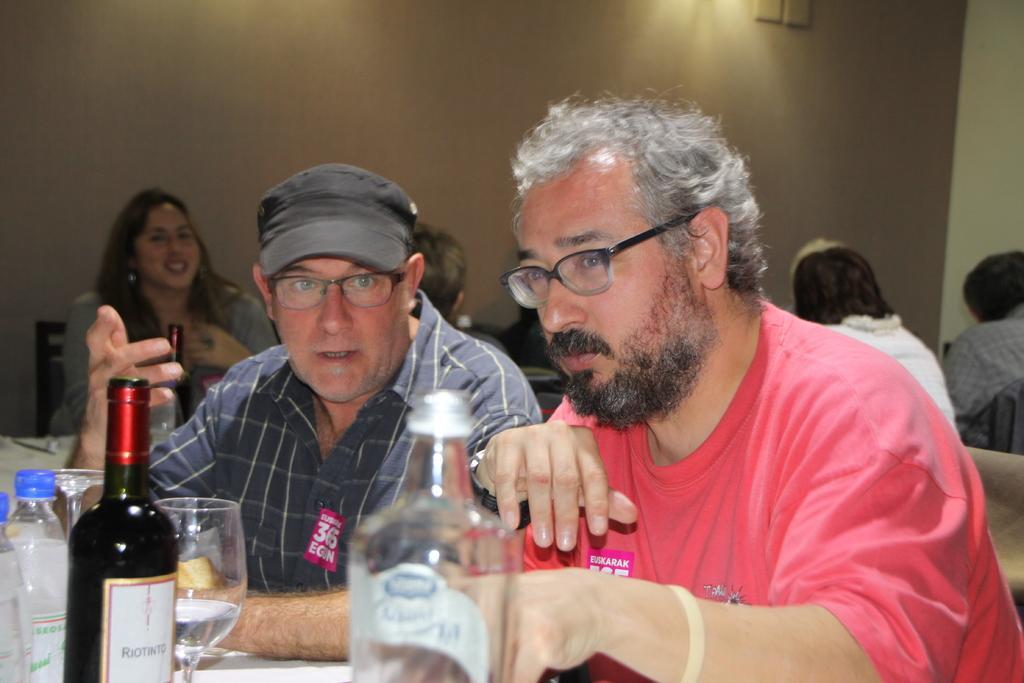Can you describe this image briefly? In this image I can see two people are sitting in-front of the table. On the table there are bottles and glasses. In the back there are also the people sitting and there is also a wall. 